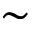<formula> <loc_0><loc_0><loc_500><loc_500>\sim</formula> 